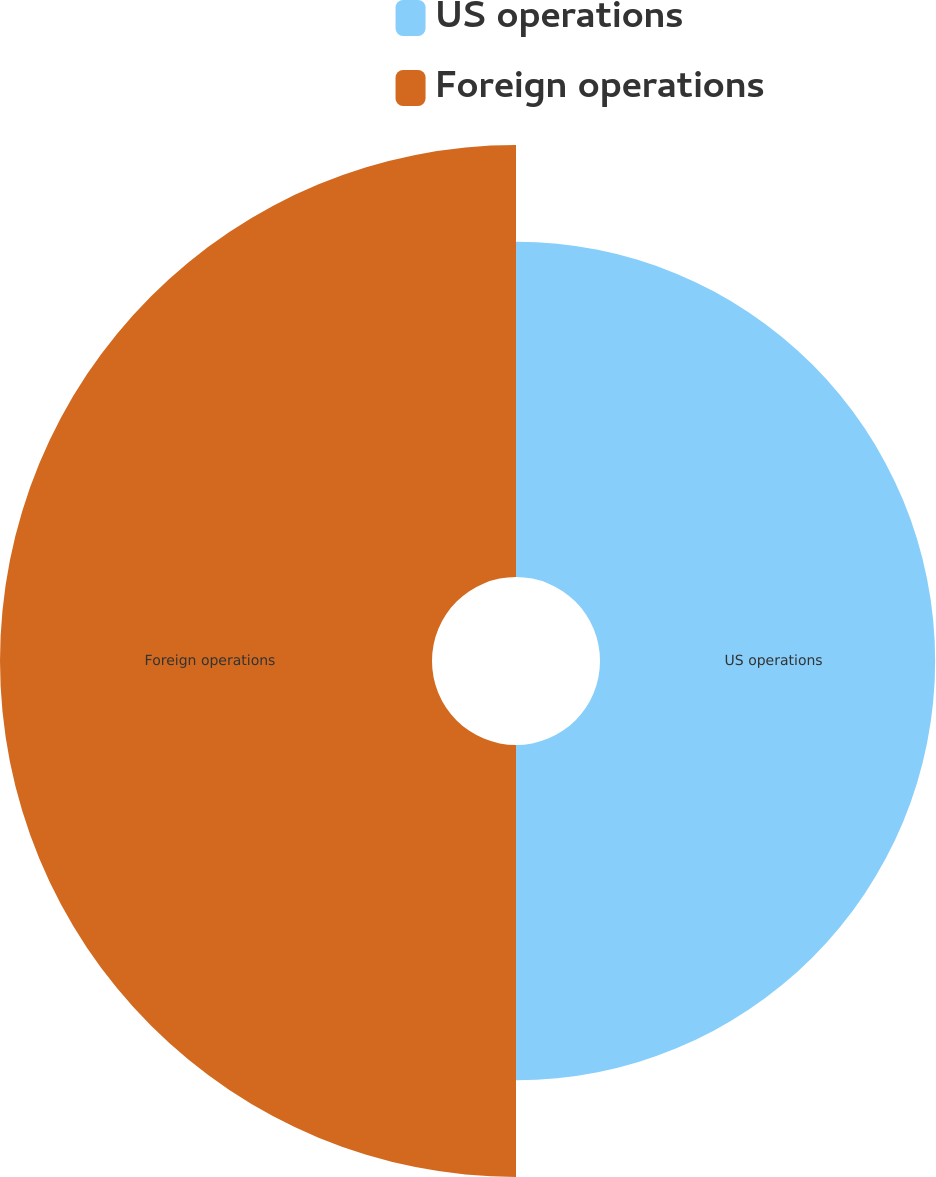Convert chart. <chart><loc_0><loc_0><loc_500><loc_500><pie_chart><fcel>US operations<fcel>Foreign operations<nl><fcel>43.69%<fcel>56.31%<nl></chart> 